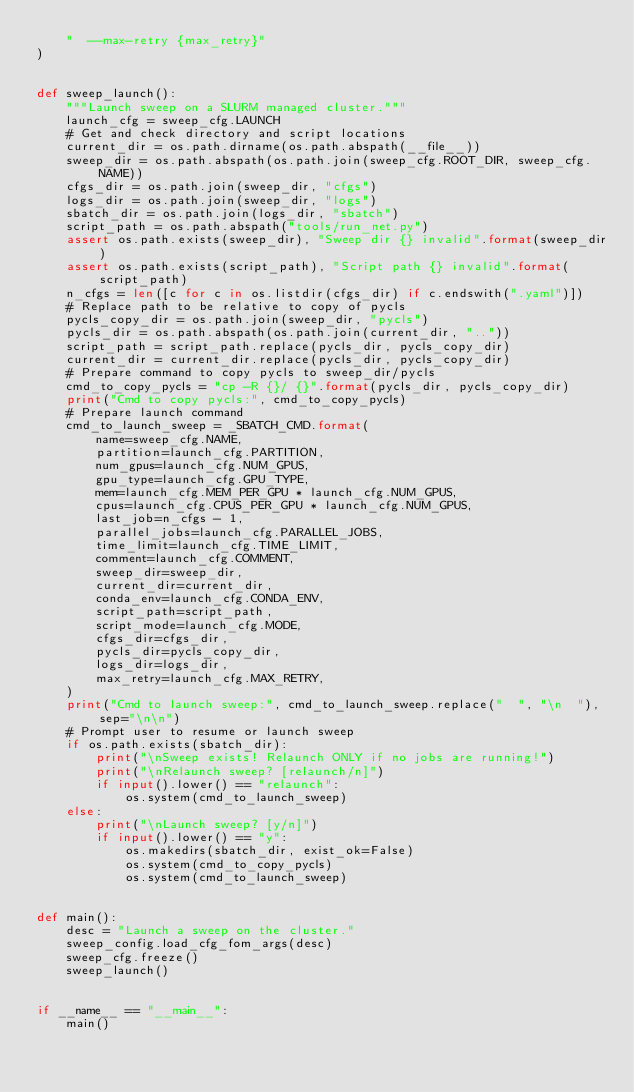Convert code to text. <code><loc_0><loc_0><loc_500><loc_500><_Python_>    "  --max-retry {max_retry}"
)


def sweep_launch():
    """Launch sweep on a SLURM managed cluster."""
    launch_cfg = sweep_cfg.LAUNCH
    # Get and check directory and script locations
    current_dir = os.path.dirname(os.path.abspath(__file__))
    sweep_dir = os.path.abspath(os.path.join(sweep_cfg.ROOT_DIR, sweep_cfg.NAME))
    cfgs_dir = os.path.join(sweep_dir, "cfgs")
    logs_dir = os.path.join(sweep_dir, "logs")
    sbatch_dir = os.path.join(logs_dir, "sbatch")
    script_path = os.path.abspath("tools/run_net.py")
    assert os.path.exists(sweep_dir), "Sweep dir {} invalid".format(sweep_dir)
    assert os.path.exists(script_path), "Script path {} invalid".format(script_path)
    n_cfgs = len([c for c in os.listdir(cfgs_dir) if c.endswith(".yaml")])
    # Replace path to be relative to copy of pycls
    pycls_copy_dir = os.path.join(sweep_dir, "pycls")
    pycls_dir = os.path.abspath(os.path.join(current_dir, ".."))
    script_path = script_path.replace(pycls_dir, pycls_copy_dir)
    current_dir = current_dir.replace(pycls_dir, pycls_copy_dir)
    # Prepare command to copy pycls to sweep_dir/pycls
    cmd_to_copy_pycls = "cp -R {}/ {}".format(pycls_dir, pycls_copy_dir)
    print("Cmd to copy pycls:", cmd_to_copy_pycls)
    # Prepare launch command
    cmd_to_launch_sweep = _SBATCH_CMD.format(
        name=sweep_cfg.NAME,
        partition=launch_cfg.PARTITION,
        num_gpus=launch_cfg.NUM_GPUS,
        gpu_type=launch_cfg.GPU_TYPE,
        mem=launch_cfg.MEM_PER_GPU * launch_cfg.NUM_GPUS,
        cpus=launch_cfg.CPUS_PER_GPU * launch_cfg.NUM_GPUS,
        last_job=n_cfgs - 1,
        parallel_jobs=launch_cfg.PARALLEL_JOBS,
        time_limit=launch_cfg.TIME_LIMIT,
        comment=launch_cfg.COMMENT,
        sweep_dir=sweep_dir,
        current_dir=current_dir,
        conda_env=launch_cfg.CONDA_ENV,
        script_path=script_path,
        script_mode=launch_cfg.MODE,
        cfgs_dir=cfgs_dir,
        pycls_dir=pycls_copy_dir,
        logs_dir=logs_dir,
        max_retry=launch_cfg.MAX_RETRY,
    )
    print("Cmd to launch sweep:", cmd_to_launch_sweep.replace("  ", "\n  "), sep="\n\n")
    # Prompt user to resume or launch sweep
    if os.path.exists(sbatch_dir):
        print("\nSweep exists! Relaunch ONLY if no jobs are running!")
        print("\nRelaunch sweep? [relaunch/n]")
        if input().lower() == "relaunch":
            os.system(cmd_to_launch_sweep)
    else:
        print("\nLaunch sweep? [y/n]")
        if input().lower() == "y":
            os.makedirs(sbatch_dir, exist_ok=False)
            os.system(cmd_to_copy_pycls)
            os.system(cmd_to_launch_sweep)


def main():
    desc = "Launch a sweep on the cluster."
    sweep_config.load_cfg_fom_args(desc)
    sweep_cfg.freeze()
    sweep_launch()


if __name__ == "__main__":
    main()
</code> 